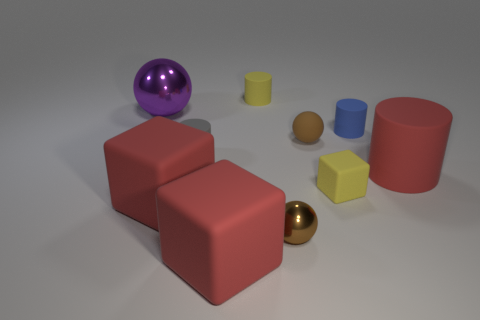Subtract 1 cylinders. How many cylinders are left? 3 Subtract all cubes. How many objects are left? 7 Add 4 cylinders. How many cylinders exist? 8 Subtract 0 purple cubes. How many objects are left? 10 Subtract all red things. Subtract all gray matte cylinders. How many objects are left? 6 Add 7 big matte cylinders. How many big matte cylinders are left? 8 